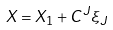Convert formula to latex. <formula><loc_0><loc_0><loc_500><loc_500>X = X _ { 1 } + C ^ { J } \xi _ { J }</formula> 